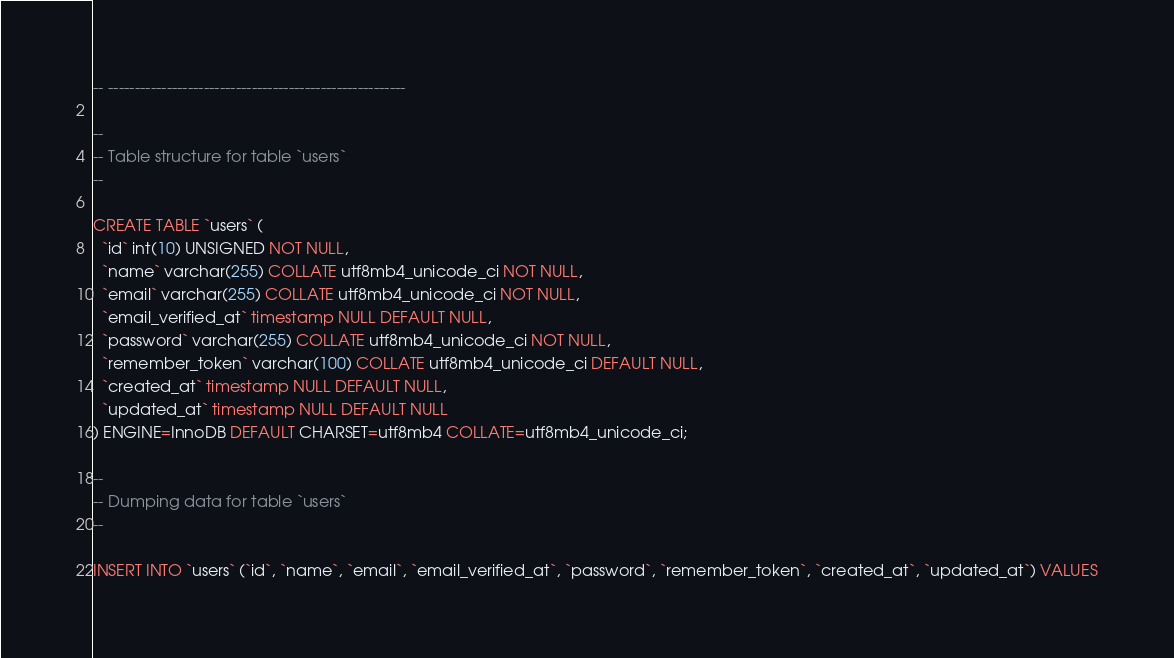Convert code to text. <code><loc_0><loc_0><loc_500><loc_500><_SQL_>-- --------------------------------------------------------

--
-- Table structure for table `users`
--

CREATE TABLE `users` (
  `id` int(10) UNSIGNED NOT NULL,
  `name` varchar(255) COLLATE utf8mb4_unicode_ci NOT NULL,
  `email` varchar(255) COLLATE utf8mb4_unicode_ci NOT NULL,
  `email_verified_at` timestamp NULL DEFAULT NULL,
  `password` varchar(255) COLLATE utf8mb4_unicode_ci NOT NULL,
  `remember_token` varchar(100) COLLATE utf8mb4_unicode_ci DEFAULT NULL,
  `created_at` timestamp NULL DEFAULT NULL,
  `updated_at` timestamp NULL DEFAULT NULL
) ENGINE=InnoDB DEFAULT CHARSET=utf8mb4 COLLATE=utf8mb4_unicode_ci;

--
-- Dumping data for table `users`
--

INSERT INTO `users` (`id`, `name`, `email`, `email_verified_at`, `password`, `remember_token`, `created_at`, `updated_at`) VALUES</code> 